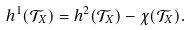Convert formula to latex. <formula><loc_0><loc_0><loc_500><loc_500>h ^ { 1 } ( \mathcal { T } _ { X } ) = h ^ { 2 } ( \mathcal { T } _ { X } ) - \chi ( \mathcal { T } _ { X } ) .</formula> 